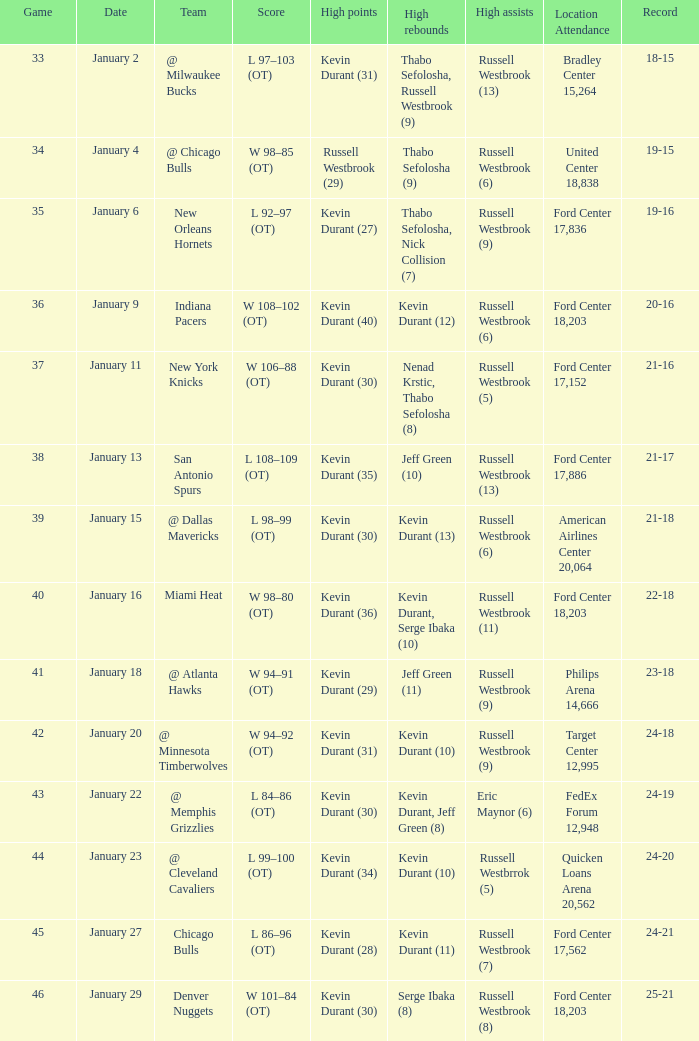Specify the site attendance on january 1 Philips Arena 14,666. 